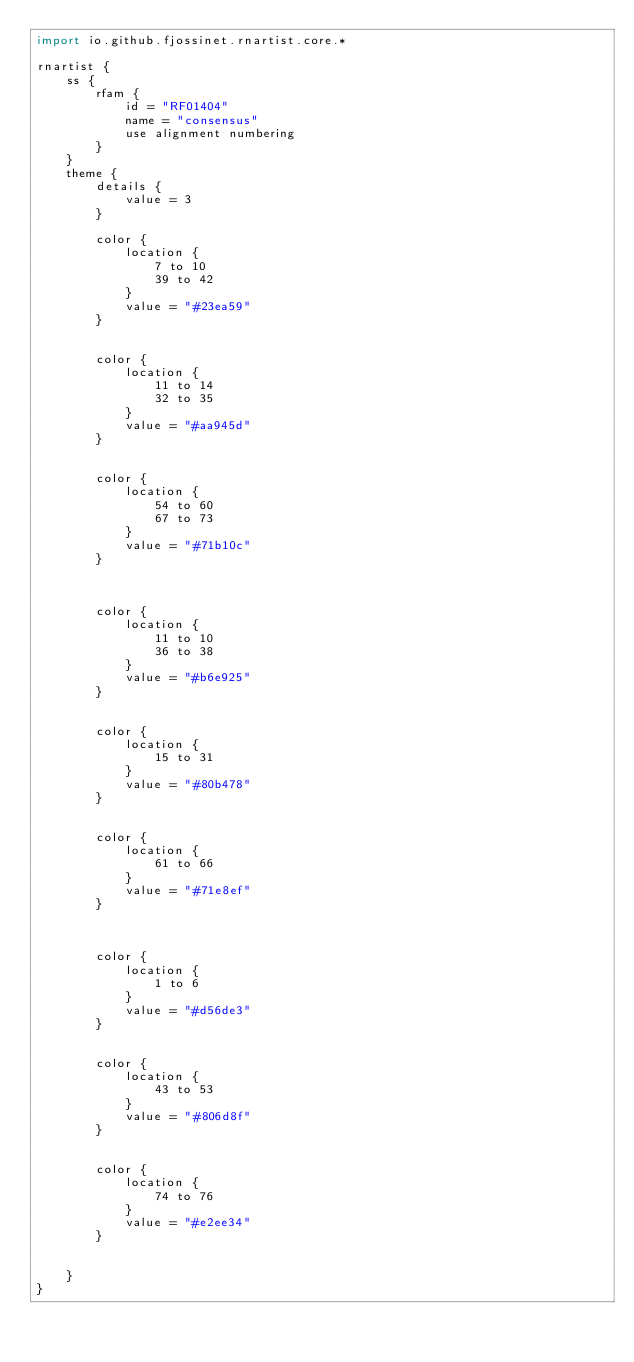Convert code to text. <code><loc_0><loc_0><loc_500><loc_500><_Kotlin_>import io.github.fjossinet.rnartist.core.*      

rnartist {
    ss {
        rfam {
            id = "RF01404"
            name = "consensus"
            use alignment numbering
        }
    }
    theme {
        details { 
            value = 3
        }

        color {
            location {
                7 to 10
                39 to 42
            }
            value = "#23ea59"
        }


        color {
            location {
                11 to 14
                32 to 35
            }
            value = "#aa945d"
        }


        color {
            location {
                54 to 60
                67 to 73
            }
            value = "#71b10c"
        }



        color {
            location {
                11 to 10
                36 to 38
            }
            value = "#b6e925"
        }


        color {
            location {
                15 to 31
            }
            value = "#80b478"
        }


        color {
            location {
                61 to 66
            }
            value = "#71e8ef"
        }



        color {
            location {
                1 to 6
            }
            value = "#d56de3"
        }


        color {
            location {
                43 to 53
            }
            value = "#806d8f"
        }


        color {
            location {
                74 to 76
            }
            value = "#e2ee34"
        }


    }
}           </code> 